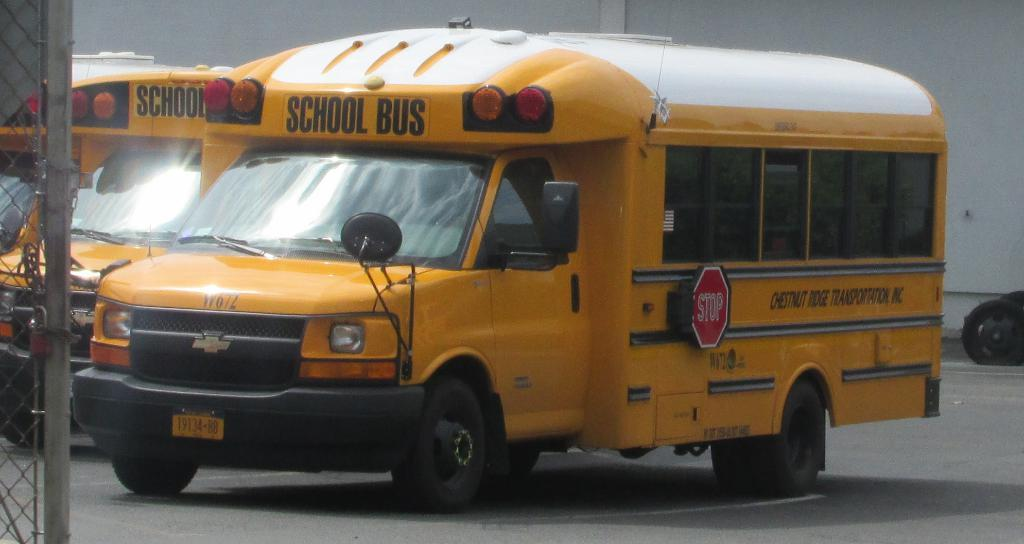How many school buses are in the image? There are two school buses in the image. What is the position of the school buses in the image? The school buses are parked on the ground. What color are the school buses in the image? The school buses are yellow in color. What is in front of the school buses in the image? There is a mesh in front of the buses. What can be seen in the background of the image? There is a wall in the background of the image. Who is the manager of the discovery made by the pocket in the image? There is no mention of a pocket, discovery, or manager in the image. 